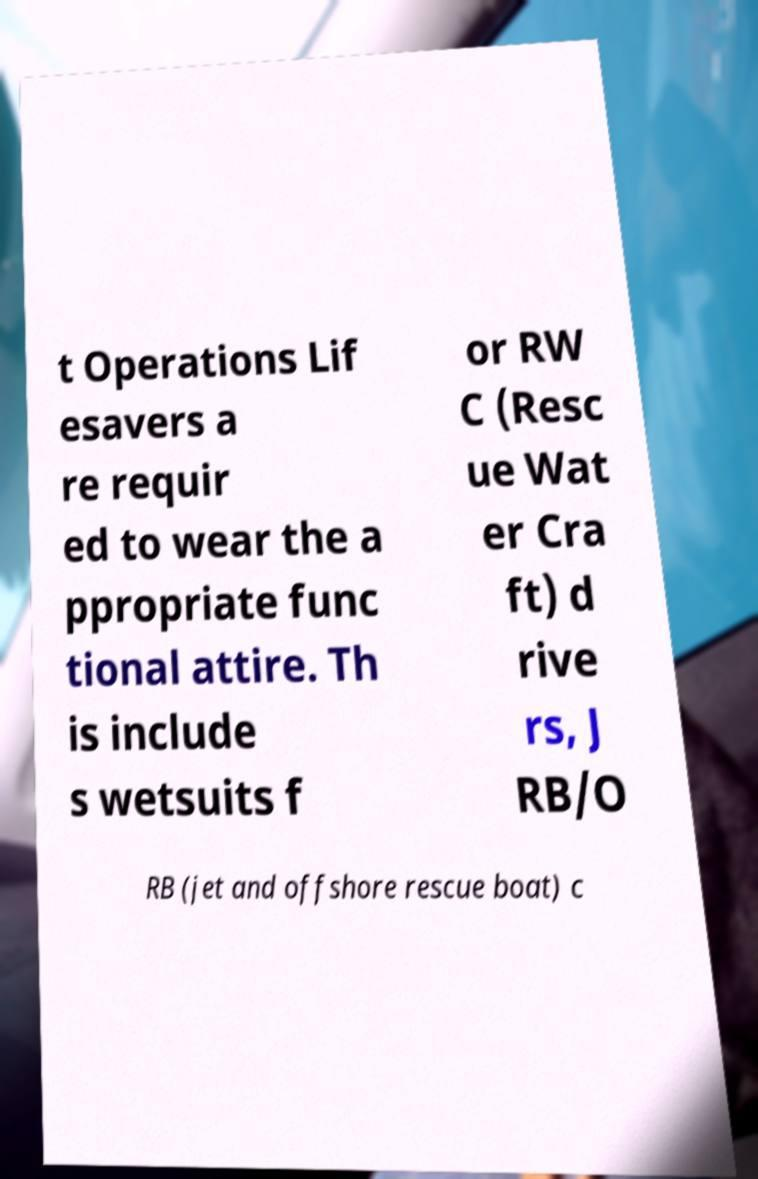What messages or text are displayed in this image? I need them in a readable, typed format. t Operations Lif esavers a re requir ed to wear the a ppropriate func tional attire. Th is include s wetsuits f or RW C (Resc ue Wat er Cra ft) d rive rs, J RB/O RB (jet and offshore rescue boat) c 